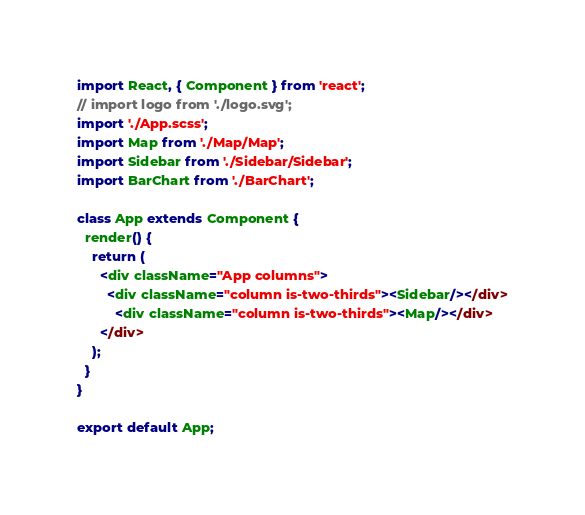<code> <loc_0><loc_0><loc_500><loc_500><_JavaScript_>import React, { Component } from 'react';
// import logo from './logo.svg';
import './App.scss';
import Map from './Map/Map';
import Sidebar from './Sidebar/Sidebar';
import BarChart from './BarChart';

class App extends Component {
  render() {
    return (
      <div className="App columns">
        <div className="column is-two-thirds"><Sidebar/></div>
          <div className="column is-two-thirds"><Map/></div>
      </div>
    );
  }
}

export default App;
</code> 